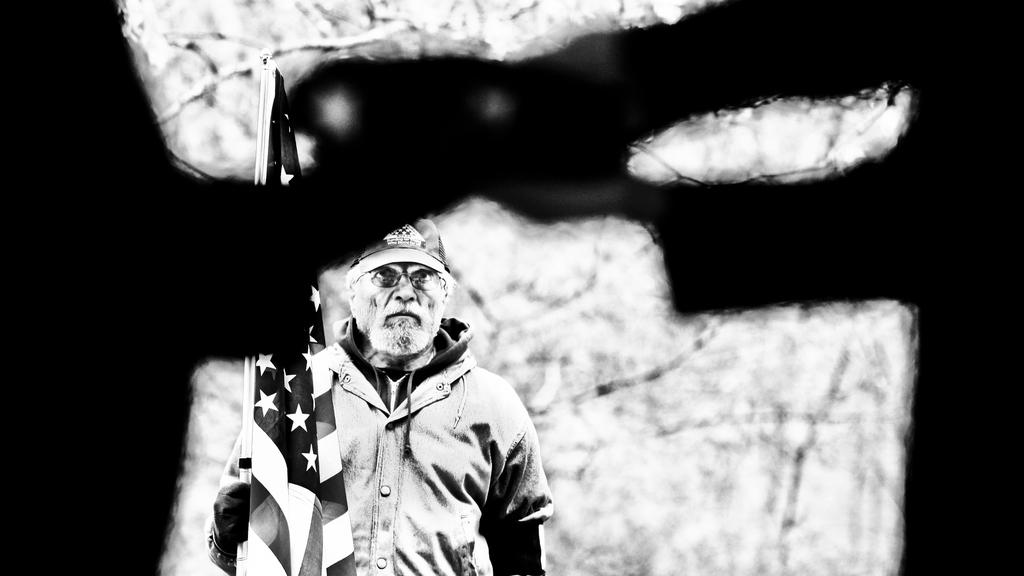What is the color scheme of the image? The image is black and white. Who or what can be seen in the image? There is a person in the image. What else is present in the image besides the person? There is a flag in the image. What is the person wearing in the image? The person is wearing a jacket and a cap. How would you describe the background of the image? The background of the image is blurry. Can you tell me how many adjustments the person made to the door in the image? There is no door present in the image, so no adjustments can be observed. What type of cave can be seen in the background of the image? There is no cave present in the image; the background is blurry. 